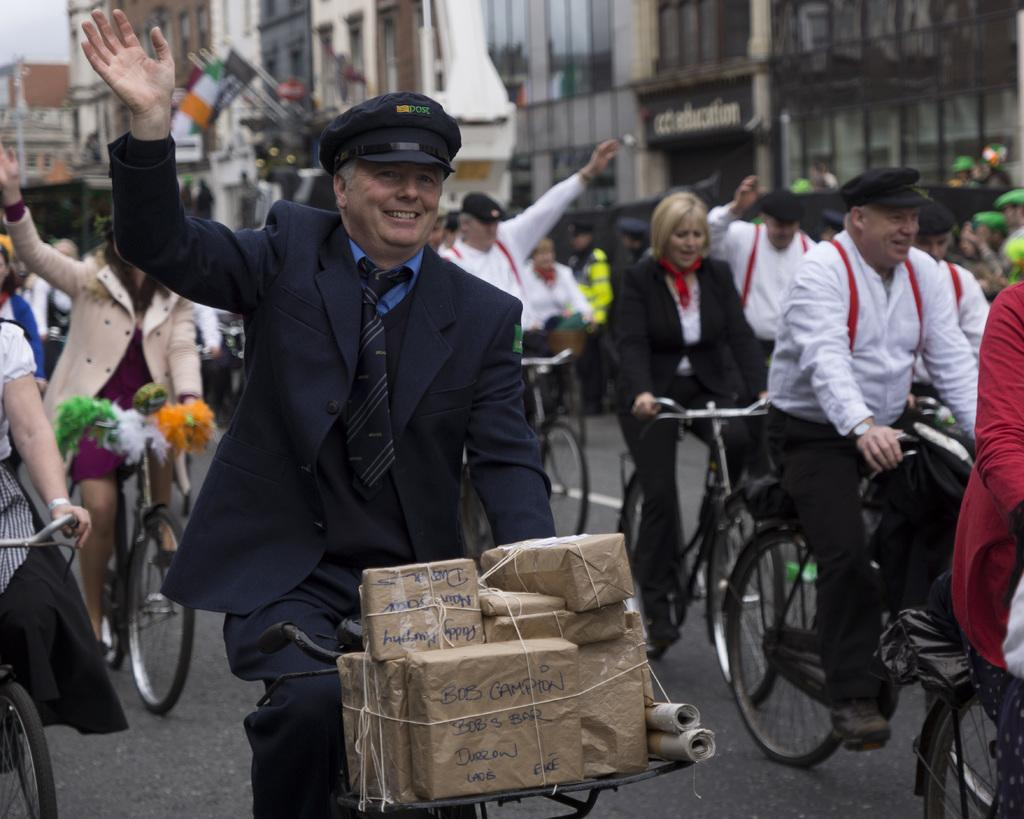What are the people in the image doing? The people in the image are riding bicycles. What action are the people performing while riding their bicycles? The people are waving their hands. What can be seen in the distance behind the people? There are buildings in the background of the image. What type of coach can be seen in the image? There is no coach present in the image; it features people riding bicycles. What tool is being used by the person on the left to fix their bicycle? There is no tool or person fixing a bicycle in the image; it only shows people riding bicycles and waving their hands. 